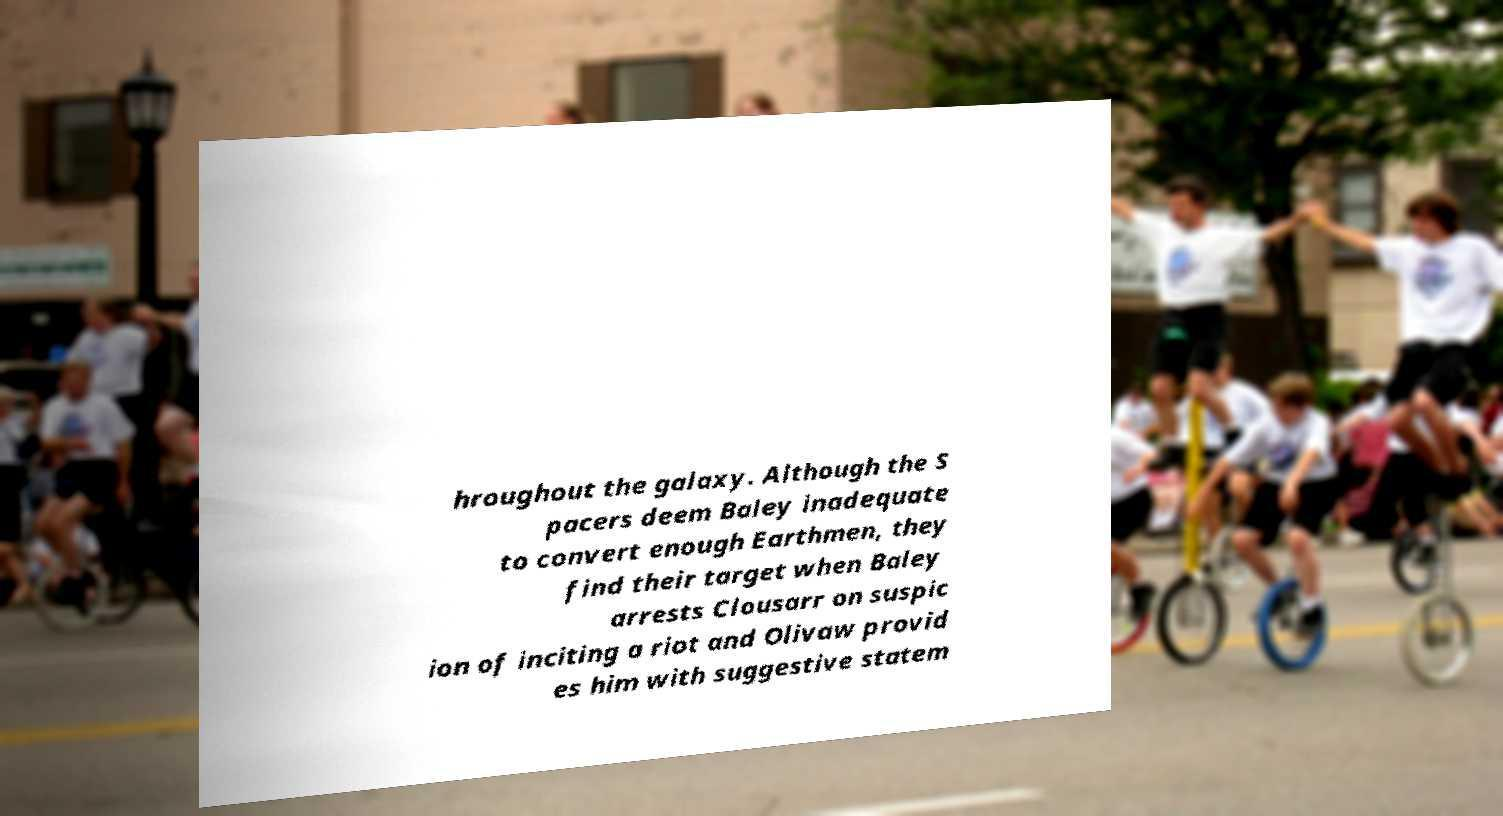Can you accurately transcribe the text from the provided image for me? hroughout the galaxy. Although the S pacers deem Baley inadequate to convert enough Earthmen, they find their target when Baley arrests Clousarr on suspic ion of inciting a riot and Olivaw provid es him with suggestive statem 